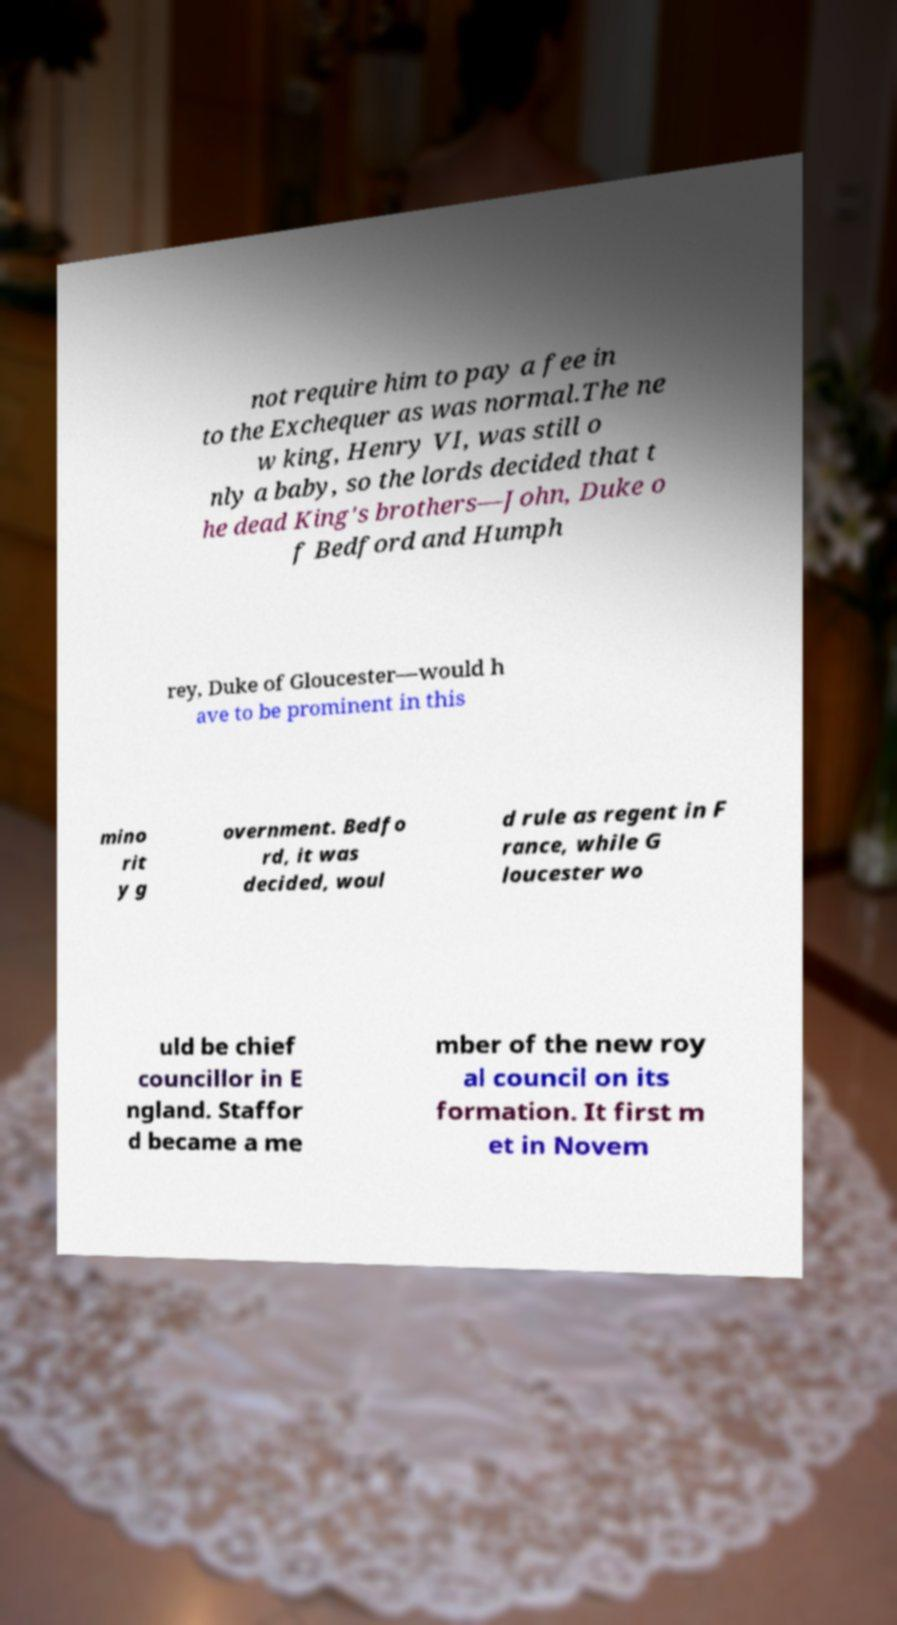Please read and relay the text visible in this image. What does it say? not require him to pay a fee in to the Exchequer as was normal.The ne w king, Henry VI, was still o nly a baby, so the lords decided that t he dead King's brothers—John, Duke o f Bedford and Humph rey, Duke of Gloucester—would h ave to be prominent in this mino rit y g overnment. Bedfo rd, it was decided, woul d rule as regent in F rance, while G loucester wo uld be chief councillor in E ngland. Staffor d became a me mber of the new roy al council on its formation. It first m et in Novem 